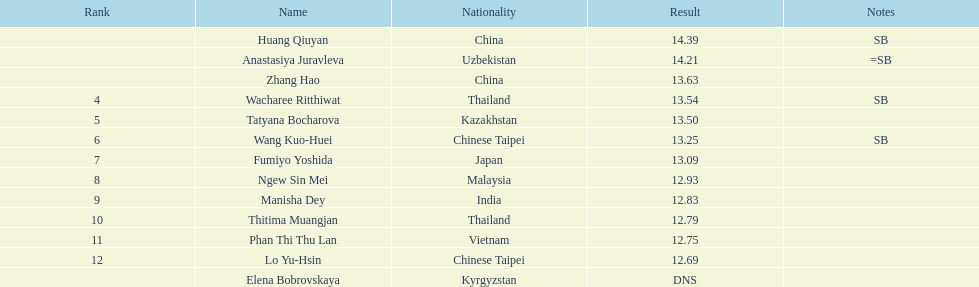What is the difference between huang qiuyan's result and fumiyo yoshida's result? 1.3. 